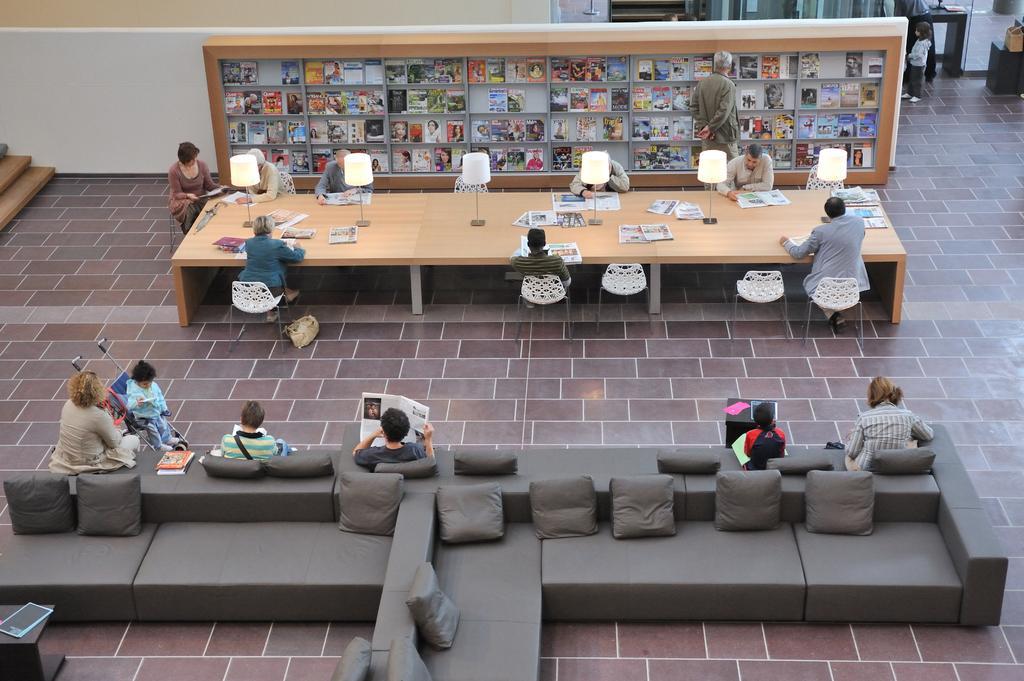Can you describe this image briefly? This picture describes about group of people, some are seated on the sofa and some are seated on the chair. one man is standing in front of bookshelf, in the middle of the image we can see lights. 